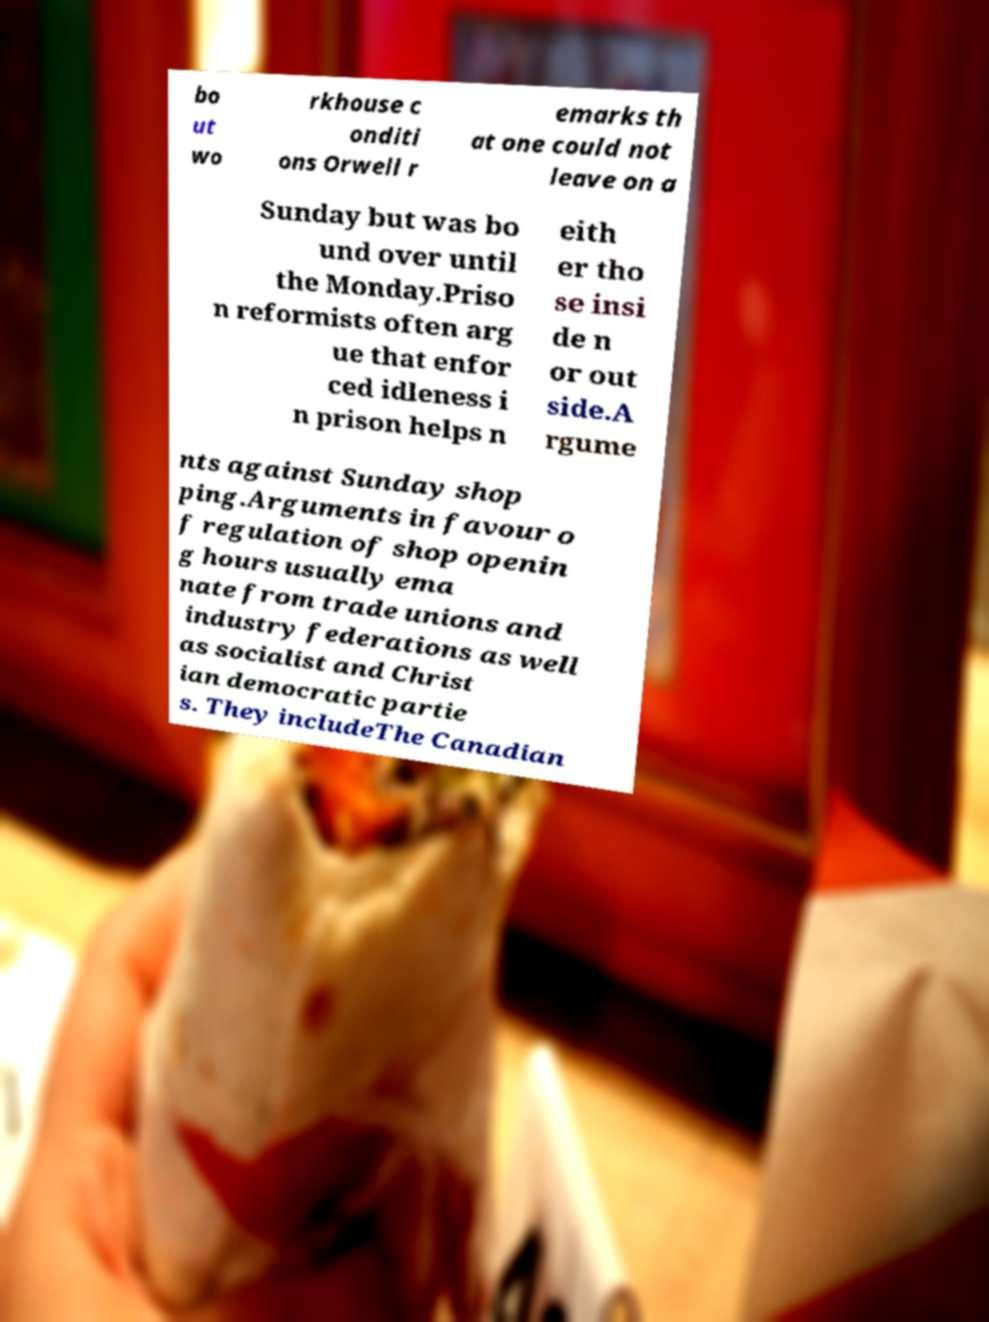What messages or text are displayed in this image? I need them in a readable, typed format. bo ut wo rkhouse c onditi ons Orwell r emarks th at one could not leave on a Sunday but was bo und over until the Monday.Priso n reformists often arg ue that enfor ced idleness i n prison helps n eith er tho se insi de n or out side.A rgume nts against Sunday shop ping.Arguments in favour o f regulation of shop openin g hours usually ema nate from trade unions and industry federations as well as socialist and Christ ian democratic partie s. They includeThe Canadian 